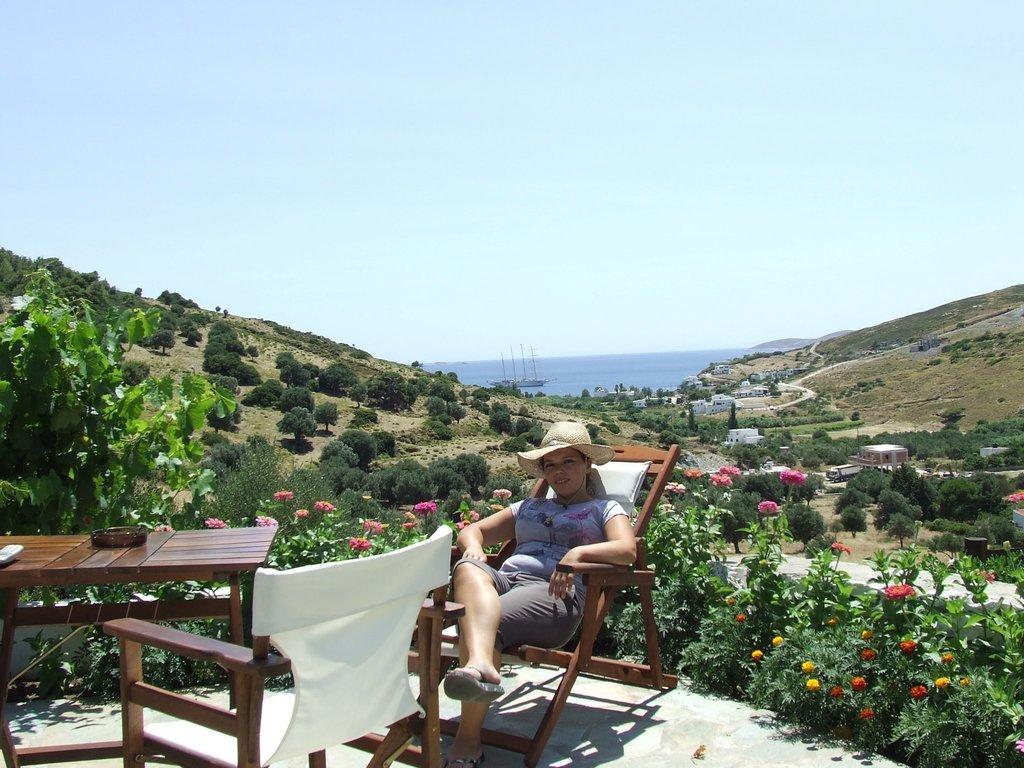Could you give a brief overview of what you see in this image? In this image I see a woman who is on this chair and I can also see there is another chair over here and there is a table on which there are few things. In the background I see the plants, trees, buildings and the sky. 